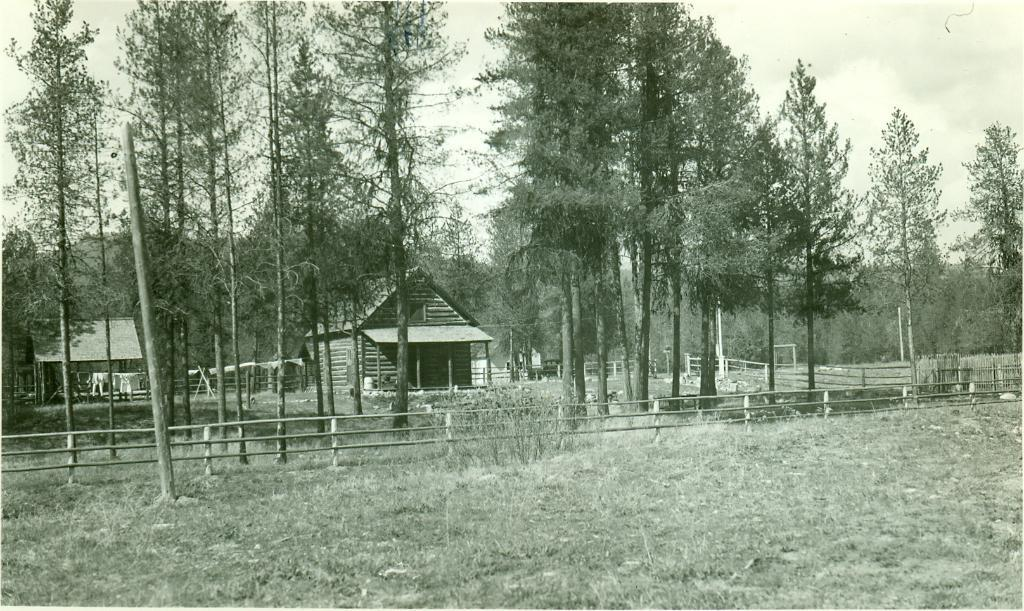What type of vegetation is present in the image? There is grass in the image. What type of structure can be seen in the image? There is a fence in the image. What other natural elements are visible in the image? There are trees in the image. What can be seen in the background of the image? There is a house and a shed in the background of the image, as well as the sky. What type of plastic material is covering the trees in the image? There is no plastic material covering the trees in the image; the trees are not covered. 